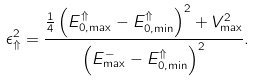Convert formula to latex. <formula><loc_0><loc_0><loc_500><loc_500>\epsilon _ { \Uparrow } ^ { 2 } = \frac { \frac { 1 } { 4 } \left ( E _ { 0 , \max } ^ { \Uparrow } - E _ { 0 , \min } ^ { \Uparrow } \right ) ^ { 2 } + V _ { \max } ^ { 2 } } { \left ( E _ { \max } ^ { - } - E _ { 0 , \min } ^ { \Uparrow } \right ) ^ { 2 } } .</formula> 